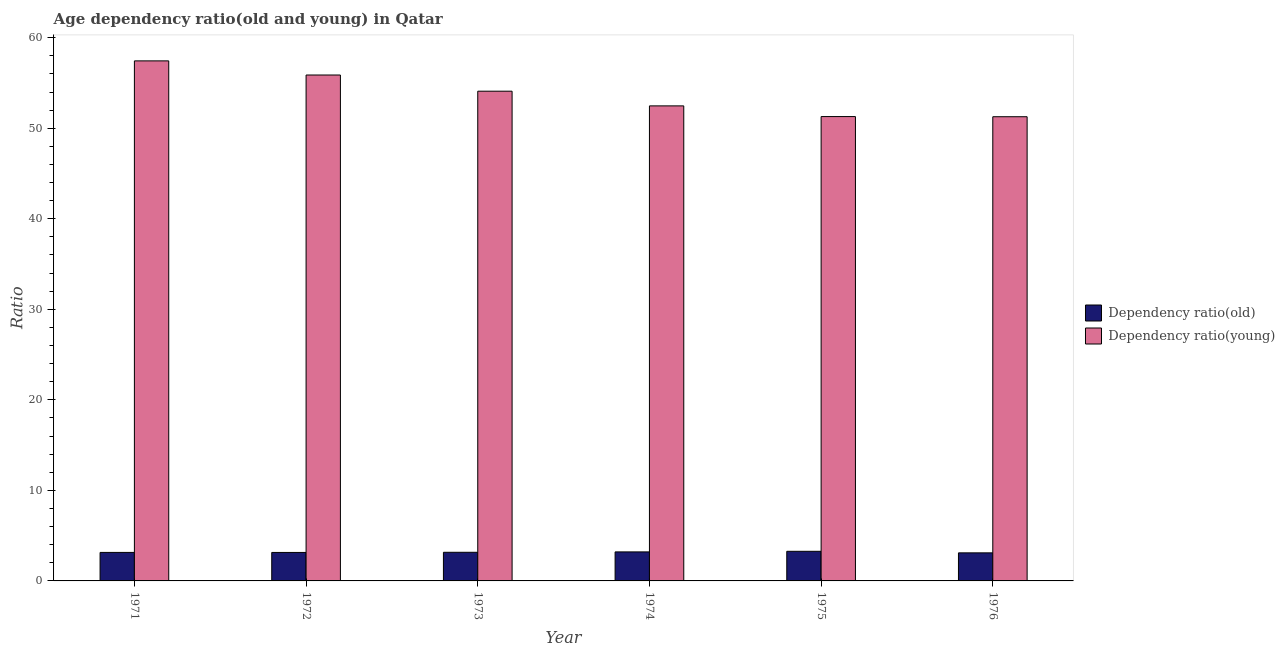Are the number of bars per tick equal to the number of legend labels?
Provide a short and direct response. Yes. Are the number of bars on each tick of the X-axis equal?
Provide a short and direct response. Yes. How many bars are there on the 1st tick from the right?
Give a very brief answer. 2. In how many cases, is the number of bars for a given year not equal to the number of legend labels?
Your answer should be compact. 0. What is the age dependency ratio(old) in 1975?
Offer a very short reply. 3.27. Across all years, what is the maximum age dependency ratio(young)?
Your answer should be compact. 57.44. Across all years, what is the minimum age dependency ratio(old)?
Keep it short and to the point. 3.1. In which year was the age dependency ratio(old) maximum?
Give a very brief answer. 1975. In which year was the age dependency ratio(young) minimum?
Offer a very short reply. 1976. What is the total age dependency ratio(old) in the graph?
Make the answer very short. 19.03. What is the difference between the age dependency ratio(young) in 1972 and that in 1974?
Give a very brief answer. 3.41. What is the difference between the age dependency ratio(old) in 1972 and the age dependency ratio(young) in 1973?
Give a very brief answer. -0.02. What is the average age dependency ratio(young) per year?
Provide a succinct answer. 53.74. What is the ratio of the age dependency ratio(old) in 1973 to that in 1976?
Ensure brevity in your answer.  1.02. What is the difference between the highest and the second highest age dependency ratio(young)?
Make the answer very short. 1.56. What is the difference between the highest and the lowest age dependency ratio(old)?
Give a very brief answer. 0.17. What does the 1st bar from the left in 1972 represents?
Offer a very short reply. Dependency ratio(old). What does the 2nd bar from the right in 1971 represents?
Your answer should be compact. Dependency ratio(old). Are all the bars in the graph horizontal?
Your response must be concise. No. How many years are there in the graph?
Make the answer very short. 6. What is the difference between two consecutive major ticks on the Y-axis?
Provide a succinct answer. 10. Does the graph contain any zero values?
Your answer should be very brief. No. Does the graph contain grids?
Give a very brief answer. No. How are the legend labels stacked?
Your answer should be very brief. Vertical. What is the title of the graph?
Ensure brevity in your answer.  Age dependency ratio(old and young) in Qatar. Does "Public funds" appear as one of the legend labels in the graph?
Give a very brief answer. No. What is the label or title of the Y-axis?
Provide a succinct answer. Ratio. What is the Ratio of Dependency ratio(old) in 1971?
Make the answer very short. 3.15. What is the Ratio in Dependency ratio(young) in 1971?
Your response must be concise. 57.44. What is the Ratio in Dependency ratio(old) in 1972?
Provide a short and direct response. 3.14. What is the Ratio in Dependency ratio(young) in 1972?
Provide a succinct answer. 55.88. What is the Ratio of Dependency ratio(old) in 1973?
Your answer should be compact. 3.16. What is the Ratio of Dependency ratio(young) in 1973?
Your answer should be very brief. 54.09. What is the Ratio in Dependency ratio(old) in 1974?
Offer a terse response. 3.2. What is the Ratio of Dependency ratio(young) in 1974?
Make the answer very short. 52.47. What is the Ratio of Dependency ratio(old) in 1975?
Your answer should be compact. 3.27. What is the Ratio in Dependency ratio(young) in 1975?
Your answer should be very brief. 51.29. What is the Ratio in Dependency ratio(old) in 1976?
Give a very brief answer. 3.1. What is the Ratio in Dependency ratio(young) in 1976?
Your answer should be very brief. 51.27. Across all years, what is the maximum Ratio of Dependency ratio(old)?
Ensure brevity in your answer.  3.27. Across all years, what is the maximum Ratio in Dependency ratio(young)?
Your response must be concise. 57.44. Across all years, what is the minimum Ratio in Dependency ratio(old)?
Your response must be concise. 3.1. Across all years, what is the minimum Ratio in Dependency ratio(young)?
Ensure brevity in your answer.  51.27. What is the total Ratio of Dependency ratio(old) in the graph?
Your response must be concise. 19.03. What is the total Ratio in Dependency ratio(young) in the graph?
Make the answer very short. 322.44. What is the difference between the Ratio of Dependency ratio(old) in 1971 and that in 1972?
Provide a short and direct response. 0. What is the difference between the Ratio in Dependency ratio(young) in 1971 and that in 1972?
Your answer should be compact. 1.56. What is the difference between the Ratio in Dependency ratio(old) in 1971 and that in 1973?
Keep it short and to the point. -0.01. What is the difference between the Ratio in Dependency ratio(young) in 1971 and that in 1973?
Your answer should be very brief. 3.35. What is the difference between the Ratio of Dependency ratio(old) in 1971 and that in 1974?
Offer a very short reply. -0.06. What is the difference between the Ratio of Dependency ratio(young) in 1971 and that in 1974?
Ensure brevity in your answer.  4.97. What is the difference between the Ratio in Dependency ratio(old) in 1971 and that in 1975?
Keep it short and to the point. -0.12. What is the difference between the Ratio in Dependency ratio(young) in 1971 and that in 1975?
Your answer should be compact. 6.15. What is the difference between the Ratio of Dependency ratio(old) in 1971 and that in 1976?
Give a very brief answer. 0.05. What is the difference between the Ratio in Dependency ratio(young) in 1971 and that in 1976?
Provide a succinct answer. 6.17. What is the difference between the Ratio of Dependency ratio(old) in 1972 and that in 1973?
Make the answer very short. -0.02. What is the difference between the Ratio in Dependency ratio(young) in 1972 and that in 1973?
Make the answer very short. 1.79. What is the difference between the Ratio of Dependency ratio(old) in 1972 and that in 1974?
Your answer should be compact. -0.06. What is the difference between the Ratio of Dependency ratio(young) in 1972 and that in 1974?
Ensure brevity in your answer.  3.41. What is the difference between the Ratio in Dependency ratio(old) in 1972 and that in 1975?
Offer a very short reply. -0.13. What is the difference between the Ratio in Dependency ratio(young) in 1972 and that in 1975?
Offer a very short reply. 4.59. What is the difference between the Ratio in Dependency ratio(old) in 1972 and that in 1976?
Provide a short and direct response. 0.04. What is the difference between the Ratio in Dependency ratio(young) in 1972 and that in 1976?
Offer a terse response. 4.61. What is the difference between the Ratio of Dependency ratio(old) in 1973 and that in 1974?
Your answer should be compact. -0.04. What is the difference between the Ratio in Dependency ratio(young) in 1973 and that in 1974?
Your response must be concise. 1.62. What is the difference between the Ratio in Dependency ratio(old) in 1973 and that in 1975?
Your answer should be very brief. -0.11. What is the difference between the Ratio of Dependency ratio(young) in 1973 and that in 1975?
Offer a very short reply. 2.8. What is the difference between the Ratio in Dependency ratio(old) in 1973 and that in 1976?
Your answer should be very brief. 0.06. What is the difference between the Ratio in Dependency ratio(young) in 1973 and that in 1976?
Your answer should be very brief. 2.82. What is the difference between the Ratio of Dependency ratio(old) in 1974 and that in 1975?
Make the answer very short. -0.07. What is the difference between the Ratio of Dependency ratio(young) in 1974 and that in 1975?
Ensure brevity in your answer.  1.18. What is the difference between the Ratio in Dependency ratio(old) in 1974 and that in 1976?
Give a very brief answer. 0.11. What is the difference between the Ratio in Dependency ratio(young) in 1974 and that in 1976?
Your answer should be compact. 1.2. What is the difference between the Ratio in Dependency ratio(old) in 1975 and that in 1976?
Provide a succinct answer. 0.17. What is the difference between the Ratio of Dependency ratio(young) in 1975 and that in 1976?
Your response must be concise. 0.02. What is the difference between the Ratio of Dependency ratio(old) in 1971 and the Ratio of Dependency ratio(young) in 1972?
Your answer should be compact. -52.73. What is the difference between the Ratio in Dependency ratio(old) in 1971 and the Ratio in Dependency ratio(young) in 1973?
Your response must be concise. -50.94. What is the difference between the Ratio of Dependency ratio(old) in 1971 and the Ratio of Dependency ratio(young) in 1974?
Provide a short and direct response. -49.32. What is the difference between the Ratio of Dependency ratio(old) in 1971 and the Ratio of Dependency ratio(young) in 1975?
Offer a terse response. -48.14. What is the difference between the Ratio of Dependency ratio(old) in 1971 and the Ratio of Dependency ratio(young) in 1976?
Offer a very short reply. -48.12. What is the difference between the Ratio of Dependency ratio(old) in 1972 and the Ratio of Dependency ratio(young) in 1973?
Make the answer very short. -50.95. What is the difference between the Ratio of Dependency ratio(old) in 1972 and the Ratio of Dependency ratio(young) in 1974?
Ensure brevity in your answer.  -49.33. What is the difference between the Ratio of Dependency ratio(old) in 1972 and the Ratio of Dependency ratio(young) in 1975?
Provide a short and direct response. -48.14. What is the difference between the Ratio of Dependency ratio(old) in 1972 and the Ratio of Dependency ratio(young) in 1976?
Keep it short and to the point. -48.13. What is the difference between the Ratio in Dependency ratio(old) in 1973 and the Ratio in Dependency ratio(young) in 1974?
Offer a terse response. -49.31. What is the difference between the Ratio of Dependency ratio(old) in 1973 and the Ratio of Dependency ratio(young) in 1975?
Offer a terse response. -48.13. What is the difference between the Ratio in Dependency ratio(old) in 1973 and the Ratio in Dependency ratio(young) in 1976?
Provide a short and direct response. -48.11. What is the difference between the Ratio in Dependency ratio(old) in 1974 and the Ratio in Dependency ratio(young) in 1975?
Offer a terse response. -48.08. What is the difference between the Ratio of Dependency ratio(old) in 1974 and the Ratio of Dependency ratio(young) in 1976?
Provide a short and direct response. -48.07. What is the difference between the Ratio of Dependency ratio(old) in 1975 and the Ratio of Dependency ratio(young) in 1976?
Provide a short and direct response. -48. What is the average Ratio of Dependency ratio(old) per year?
Your answer should be very brief. 3.17. What is the average Ratio in Dependency ratio(young) per year?
Ensure brevity in your answer.  53.74. In the year 1971, what is the difference between the Ratio in Dependency ratio(old) and Ratio in Dependency ratio(young)?
Provide a short and direct response. -54.29. In the year 1972, what is the difference between the Ratio of Dependency ratio(old) and Ratio of Dependency ratio(young)?
Your response must be concise. -52.74. In the year 1973, what is the difference between the Ratio of Dependency ratio(old) and Ratio of Dependency ratio(young)?
Keep it short and to the point. -50.93. In the year 1974, what is the difference between the Ratio of Dependency ratio(old) and Ratio of Dependency ratio(young)?
Offer a terse response. -49.26. In the year 1975, what is the difference between the Ratio of Dependency ratio(old) and Ratio of Dependency ratio(young)?
Provide a succinct answer. -48.02. In the year 1976, what is the difference between the Ratio of Dependency ratio(old) and Ratio of Dependency ratio(young)?
Your answer should be compact. -48.17. What is the ratio of the Ratio in Dependency ratio(old) in 1971 to that in 1972?
Offer a terse response. 1. What is the ratio of the Ratio in Dependency ratio(young) in 1971 to that in 1972?
Your answer should be very brief. 1.03. What is the ratio of the Ratio of Dependency ratio(young) in 1971 to that in 1973?
Keep it short and to the point. 1.06. What is the ratio of the Ratio in Dependency ratio(old) in 1971 to that in 1974?
Your response must be concise. 0.98. What is the ratio of the Ratio of Dependency ratio(young) in 1971 to that in 1974?
Your answer should be compact. 1.09. What is the ratio of the Ratio in Dependency ratio(old) in 1971 to that in 1975?
Provide a succinct answer. 0.96. What is the ratio of the Ratio of Dependency ratio(young) in 1971 to that in 1975?
Your answer should be very brief. 1.12. What is the ratio of the Ratio of Dependency ratio(old) in 1971 to that in 1976?
Provide a short and direct response. 1.02. What is the ratio of the Ratio in Dependency ratio(young) in 1971 to that in 1976?
Make the answer very short. 1.12. What is the ratio of the Ratio in Dependency ratio(young) in 1972 to that in 1973?
Your response must be concise. 1.03. What is the ratio of the Ratio in Dependency ratio(old) in 1972 to that in 1974?
Provide a succinct answer. 0.98. What is the ratio of the Ratio in Dependency ratio(young) in 1972 to that in 1974?
Offer a very short reply. 1.06. What is the ratio of the Ratio in Dependency ratio(old) in 1972 to that in 1975?
Offer a terse response. 0.96. What is the ratio of the Ratio of Dependency ratio(young) in 1972 to that in 1975?
Offer a terse response. 1.09. What is the ratio of the Ratio of Dependency ratio(old) in 1972 to that in 1976?
Give a very brief answer. 1.01. What is the ratio of the Ratio in Dependency ratio(young) in 1972 to that in 1976?
Your response must be concise. 1.09. What is the ratio of the Ratio in Dependency ratio(young) in 1973 to that in 1974?
Offer a very short reply. 1.03. What is the ratio of the Ratio of Dependency ratio(old) in 1973 to that in 1975?
Your response must be concise. 0.97. What is the ratio of the Ratio in Dependency ratio(young) in 1973 to that in 1975?
Keep it short and to the point. 1.05. What is the ratio of the Ratio of Dependency ratio(old) in 1973 to that in 1976?
Your answer should be compact. 1.02. What is the ratio of the Ratio in Dependency ratio(young) in 1973 to that in 1976?
Keep it short and to the point. 1.05. What is the ratio of the Ratio in Dependency ratio(old) in 1974 to that in 1975?
Give a very brief answer. 0.98. What is the ratio of the Ratio in Dependency ratio(old) in 1974 to that in 1976?
Your response must be concise. 1.03. What is the ratio of the Ratio in Dependency ratio(young) in 1974 to that in 1976?
Keep it short and to the point. 1.02. What is the ratio of the Ratio in Dependency ratio(old) in 1975 to that in 1976?
Offer a very short reply. 1.06. What is the difference between the highest and the second highest Ratio of Dependency ratio(old)?
Provide a succinct answer. 0.07. What is the difference between the highest and the second highest Ratio in Dependency ratio(young)?
Provide a short and direct response. 1.56. What is the difference between the highest and the lowest Ratio of Dependency ratio(old)?
Give a very brief answer. 0.17. What is the difference between the highest and the lowest Ratio of Dependency ratio(young)?
Your answer should be compact. 6.17. 